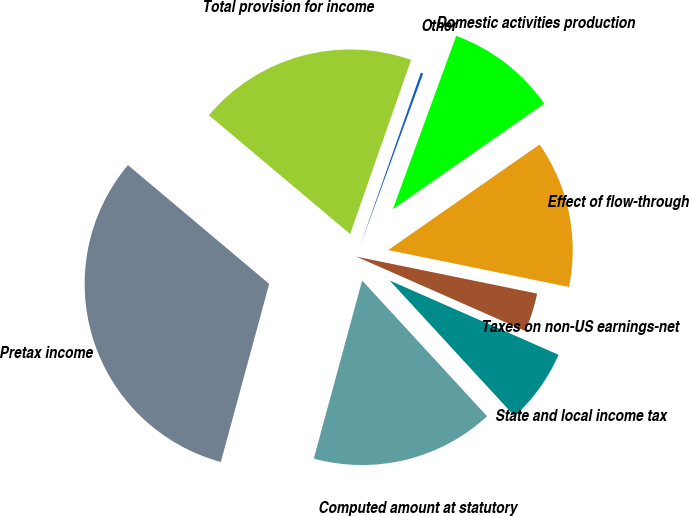<chart> <loc_0><loc_0><loc_500><loc_500><pie_chart><fcel>Pretax income<fcel>Computed amount at statutory<fcel>State and local income tax<fcel>Taxes on non-US earnings-net<fcel>Effect of flow-through<fcel>Domestic activities production<fcel>Other<fcel>Total provision for income<nl><fcel>31.91%<fcel>16.06%<fcel>6.56%<fcel>3.39%<fcel>12.9%<fcel>9.73%<fcel>0.22%<fcel>19.23%<nl></chart> 